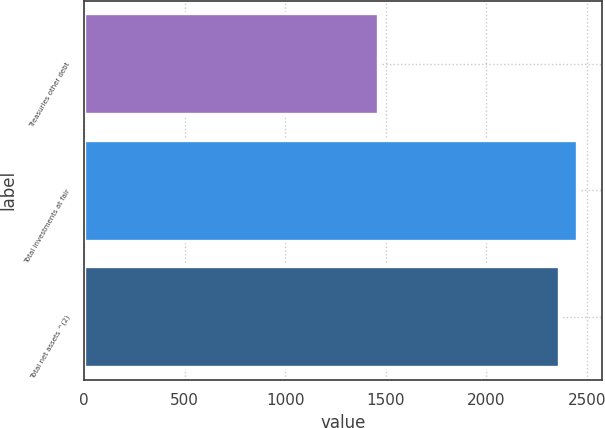<chart> <loc_0><loc_0><loc_500><loc_500><bar_chart><fcel>Treasuries other debt<fcel>Total investments at fair<fcel>Total net assets ^(2)<nl><fcel>1459<fcel>2451.9<fcel>2361<nl></chart> 